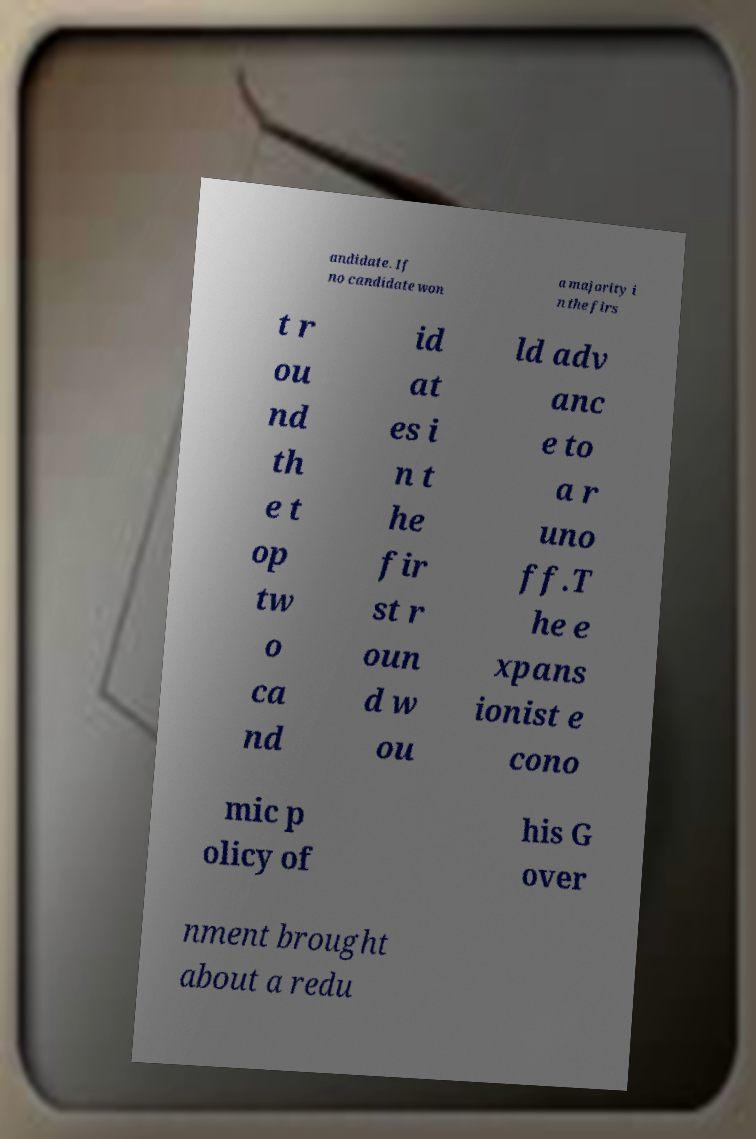Can you read and provide the text displayed in the image?This photo seems to have some interesting text. Can you extract and type it out for me? andidate. If no candidate won a majority i n the firs t r ou nd th e t op tw o ca nd id at es i n t he fir st r oun d w ou ld adv anc e to a r uno ff.T he e xpans ionist e cono mic p olicy of his G over nment brought about a redu 